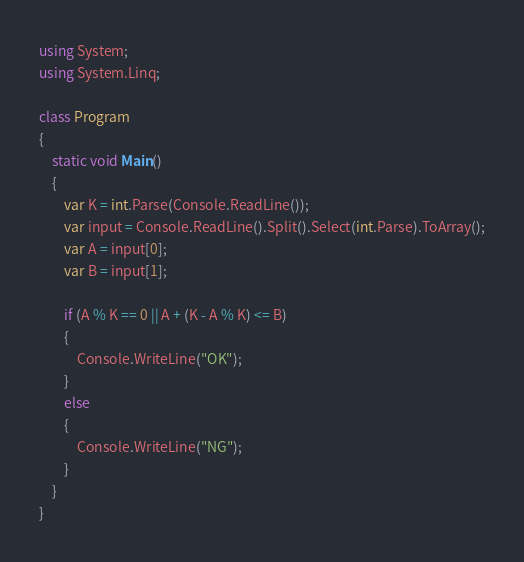Convert code to text. <code><loc_0><loc_0><loc_500><loc_500><_C#_>using System;
using System.Linq;

class Program
{
    static void Main()
    {
        var K = int.Parse(Console.ReadLine());
        var input = Console.ReadLine().Split().Select(int.Parse).ToArray();
        var A = input[0];
        var B = input[1];

        if (A % K == 0 || A + (K - A % K) <= B)
        {
            Console.WriteLine("OK");
        }
        else
        {
            Console.WriteLine("NG");
        }
    }
}
</code> 